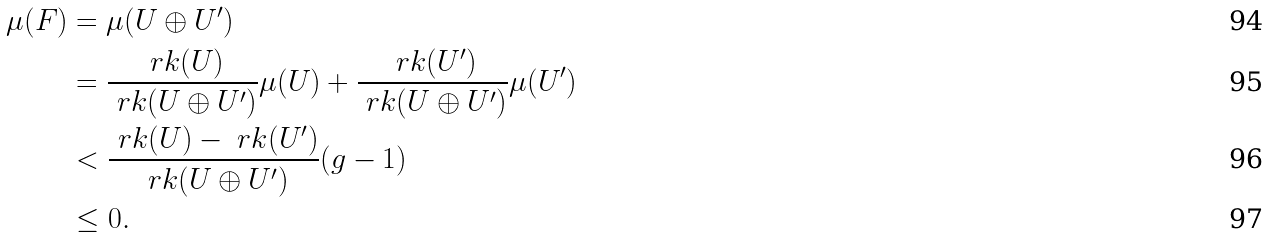<formula> <loc_0><loc_0><loc_500><loc_500>\mu ( F ) & = \mu ( U \oplus U ^ { \prime } ) \\ & = \frac { \ r k ( U ) } { \ r k ( U \oplus U ^ { \prime } ) } \mu ( U ) + \frac { \ r k ( U ^ { \prime } ) } { \ r k ( U \oplus U ^ { \prime } ) } \mu ( U ^ { \prime } ) \\ & < \frac { \ r k ( U ) - \ r k ( U ^ { \prime } ) } { \ r k ( U \oplus U ^ { \prime } ) } ( g - 1 ) \\ & \leq 0 .</formula> 